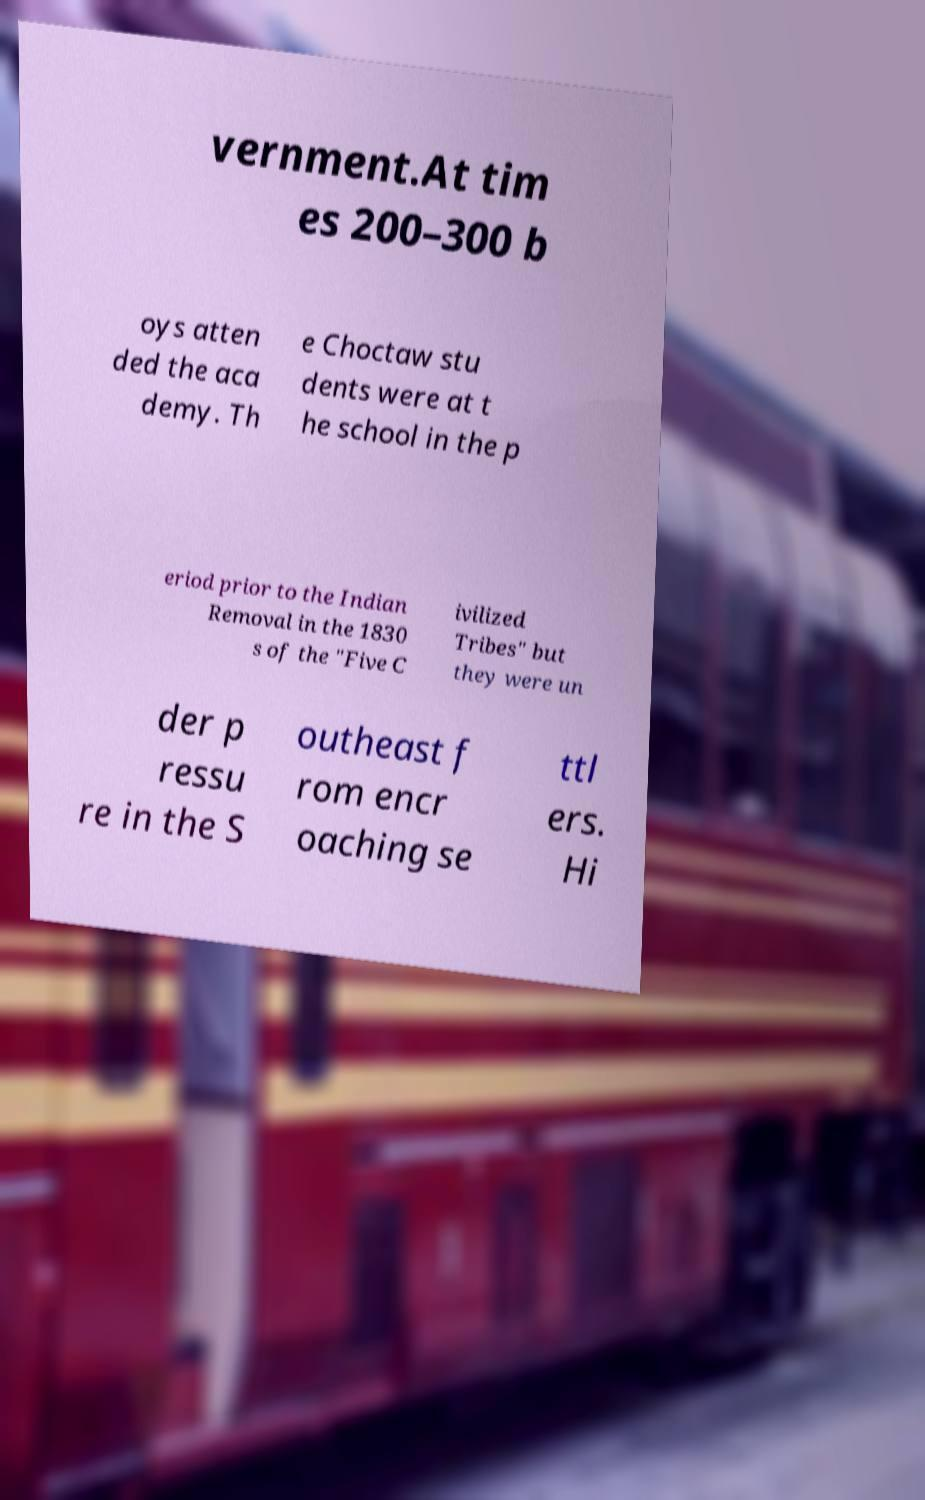Please read and relay the text visible in this image. What does it say? vernment.At tim es 200–300 b oys atten ded the aca demy. Th e Choctaw stu dents were at t he school in the p eriod prior to the Indian Removal in the 1830 s of the "Five C ivilized Tribes" but they were un der p ressu re in the S outheast f rom encr oaching se ttl ers. Hi 